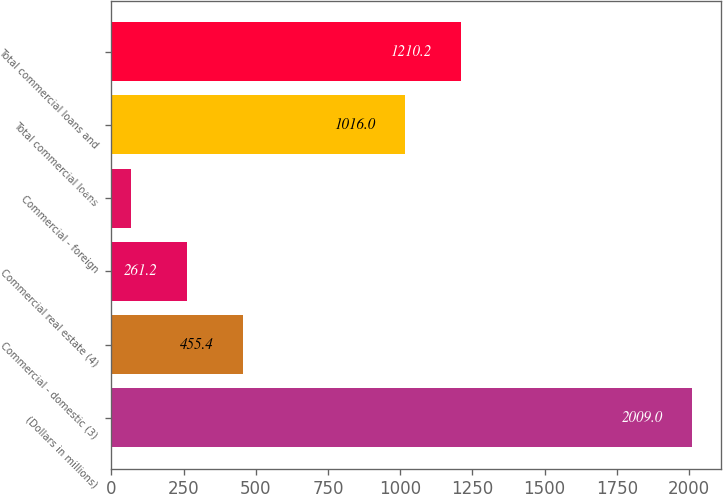<chart> <loc_0><loc_0><loc_500><loc_500><bar_chart><fcel>(Dollars in millions)<fcel>Commercial - domestic (3)<fcel>Commercial real estate (4)<fcel>Commercial - foreign<fcel>Total commercial loans<fcel>Total commercial loans and<nl><fcel>2009<fcel>455.4<fcel>261.2<fcel>67<fcel>1016<fcel>1210.2<nl></chart> 